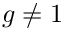Convert formula to latex. <formula><loc_0><loc_0><loc_500><loc_500>g \neq 1</formula> 